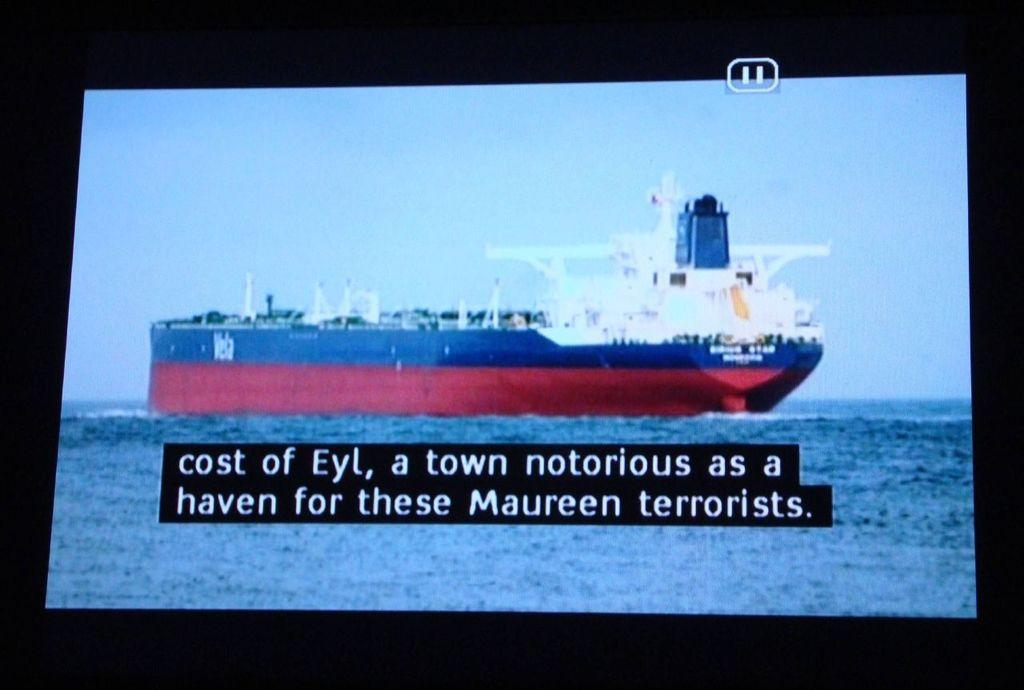<image>
Provide a brief description of the given image. Cargo Ship on a television screen with the caption: cost of Eyl, a town notorious as a haven for these Maureen terrorists. 